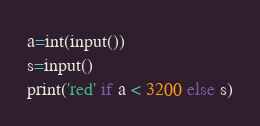<code> <loc_0><loc_0><loc_500><loc_500><_Python_>a=int(input())
s=input()
print('red' if a < 3200 else s)</code> 